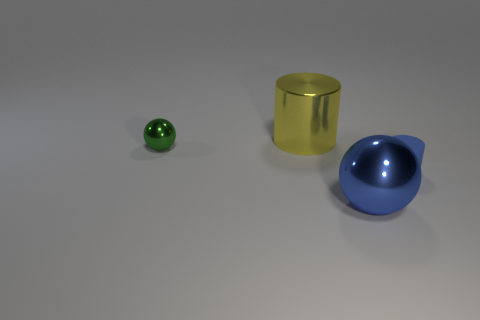What material is the large blue ball?
Give a very brief answer. Metal. Does the big sphere have the same material as the small blue cylinder?
Ensure brevity in your answer.  No. Is the number of blue balls less than the number of metallic things?
Give a very brief answer. Yes. What is the material of the thing that is in front of the big yellow metal cylinder and on the left side of the large sphere?
Keep it short and to the point. Metal. There is a large object behind the blue sphere; is there a large yellow metallic object that is to the right of it?
Keep it short and to the point. No. What number of things are tiny gray cylinders or matte cylinders?
Your answer should be very brief. 1. What shape is the object that is both in front of the big yellow thing and to the left of the large blue metal ball?
Your answer should be very brief. Sphere. Is the thing behind the small metal sphere made of the same material as the green ball?
Your answer should be compact. Yes. How many things are small red metal things or things in front of the yellow shiny thing?
Keep it short and to the point. 3. The large cylinder that is the same material as the blue sphere is what color?
Give a very brief answer. Yellow. 